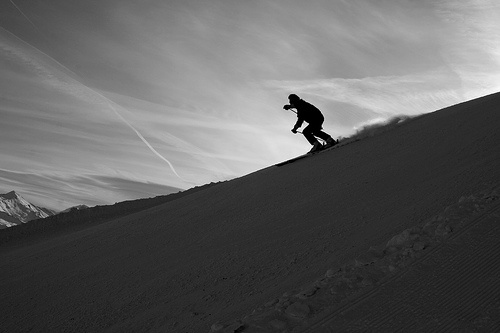Describe the objects in this image and their specific colors. I can see people in black, lightgray, darkgray, and gray tones, snowboard in black, gray, lightgray, and darkgray tones, and skis in black and gray tones in this image. 